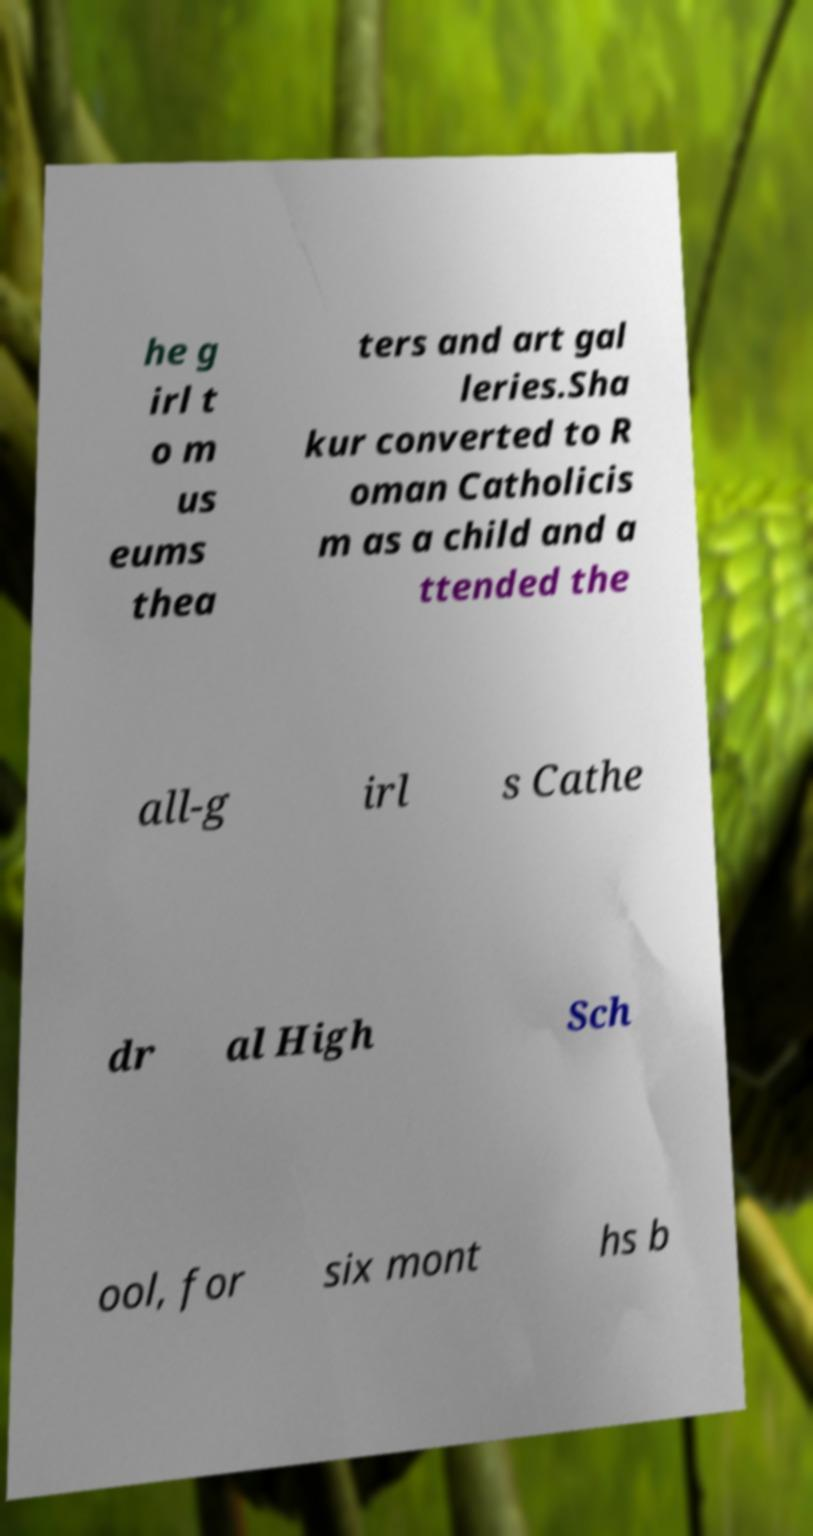Please identify and transcribe the text found in this image. he g irl t o m us eums thea ters and art gal leries.Sha kur converted to R oman Catholicis m as a child and a ttended the all-g irl s Cathe dr al High Sch ool, for six mont hs b 